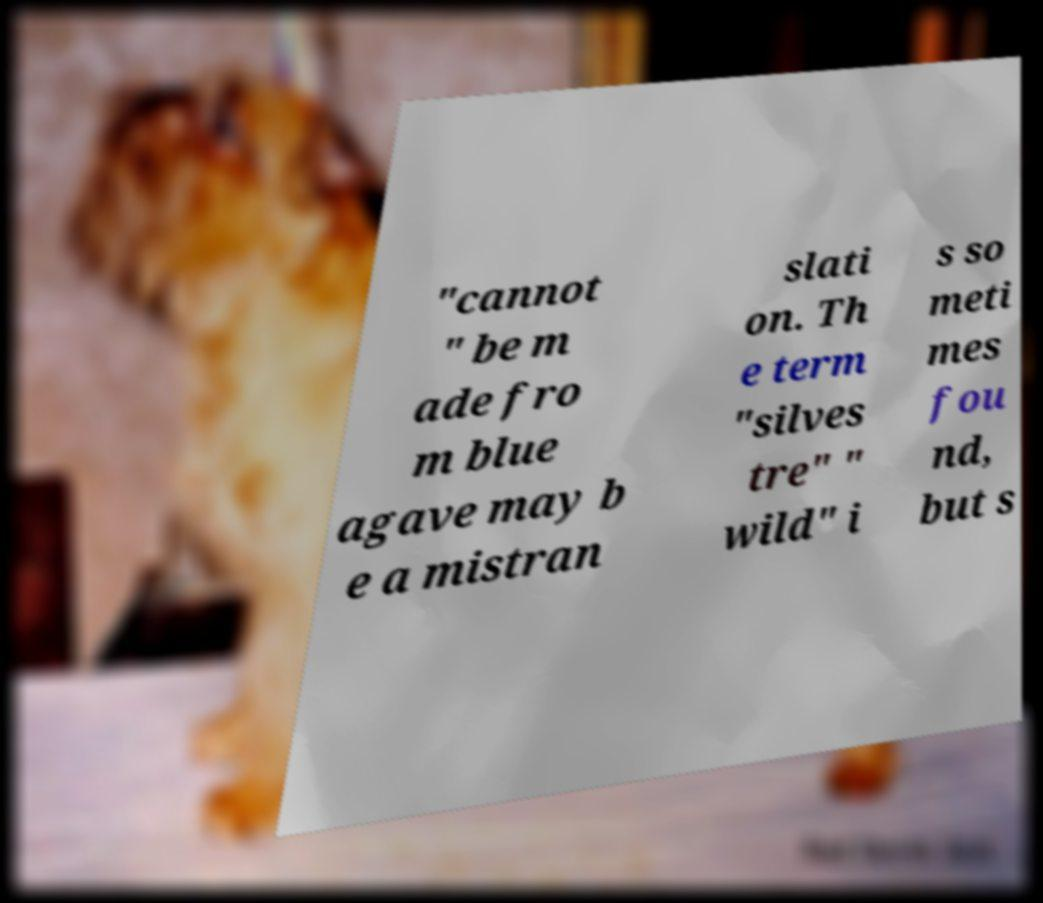Can you accurately transcribe the text from the provided image for me? "cannot " be m ade fro m blue agave may b e a mistran slati on. Th e term "silves tre" " wild" i s so meti mes fou nd, but s 